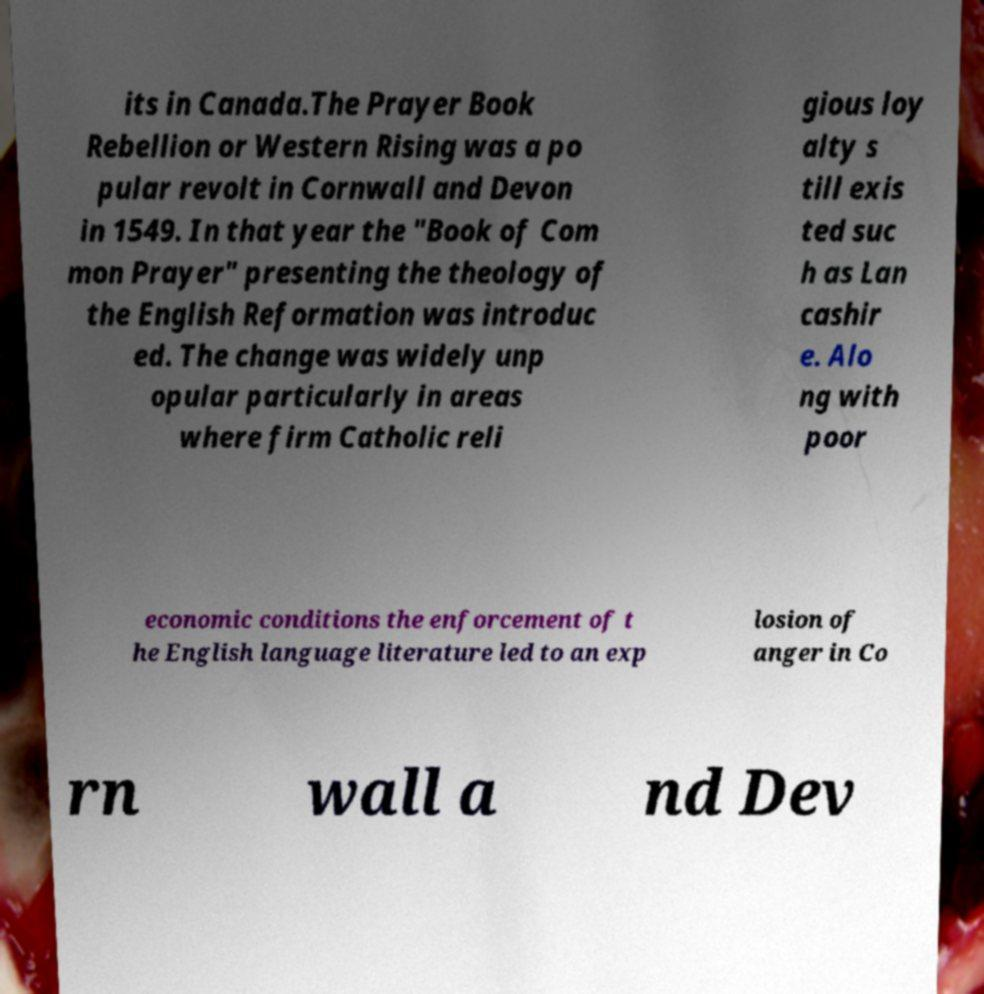Could you assist in decoding the text presented in this image and type it out clearly? its in Canada.The Prayer Book Rebellion or Western Rising was a po pular revolt in Cornwall and Devon in 1549. In that year the "Book of Com mon Prayer" presenting the theology of the English Reformation was introduc ed. The change was widely unp opular particularly in areas where firm Catholic reli gious loy alty s till exis ted suc h as Lan cashir e. Alo ng with poor economic conditions the enforcement of t he English language literature led to an exp losion of anger in Co rn wall a nd Dev 